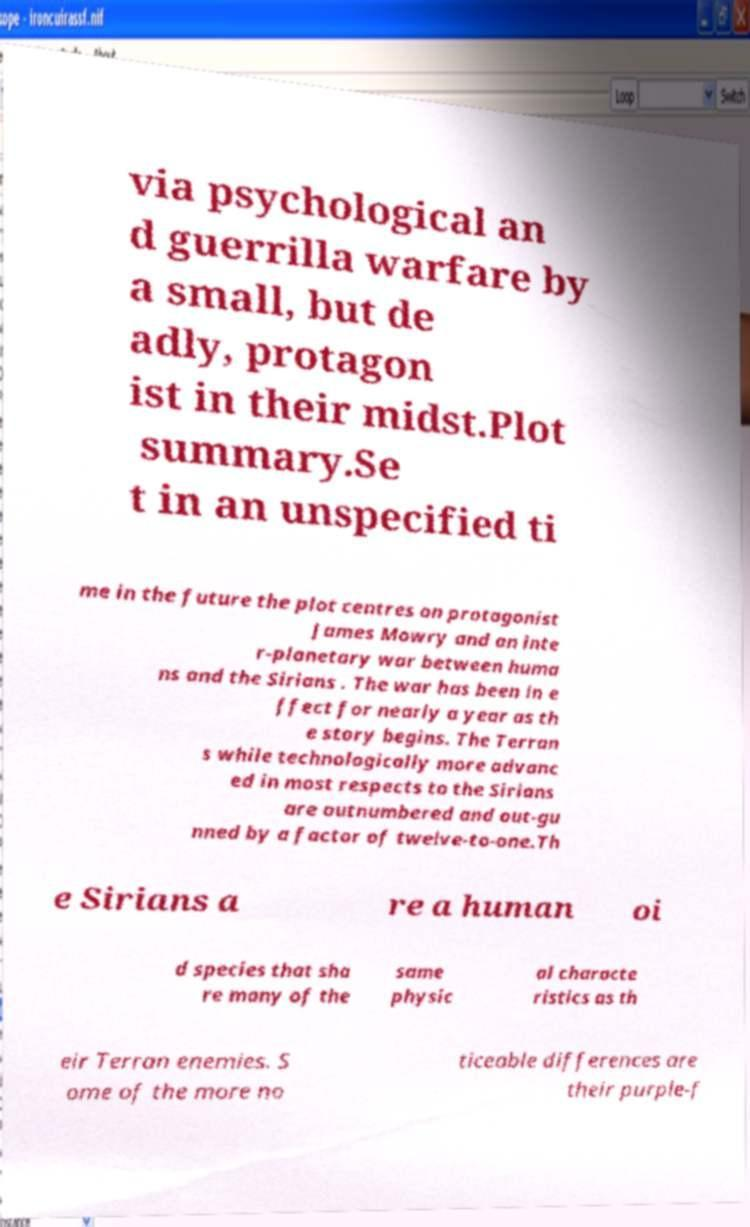I need the written content from this picture converted into text. Can you do that? via psychological an d guerrilla warfare by a small, but de adly, protagon ist in their midst.Plot summary.Se t in an unspecified ti me in the future the plot centres on protagonist James Mowry and an inte r-planetary war between huma ns and the Sirians . The war has been in e ffect for nearly a year as th e story begins. The Terran s while technologically more advanc ed in most respects to the Sirians are outnumbered and out-gu nned by a factor of twelve-to-one.Th e Sirians a re a human oi d species that sha re many of the same physic al characte ristics as th eir Terran enemies. S ome of the more no ticeable differences are their purple-f 